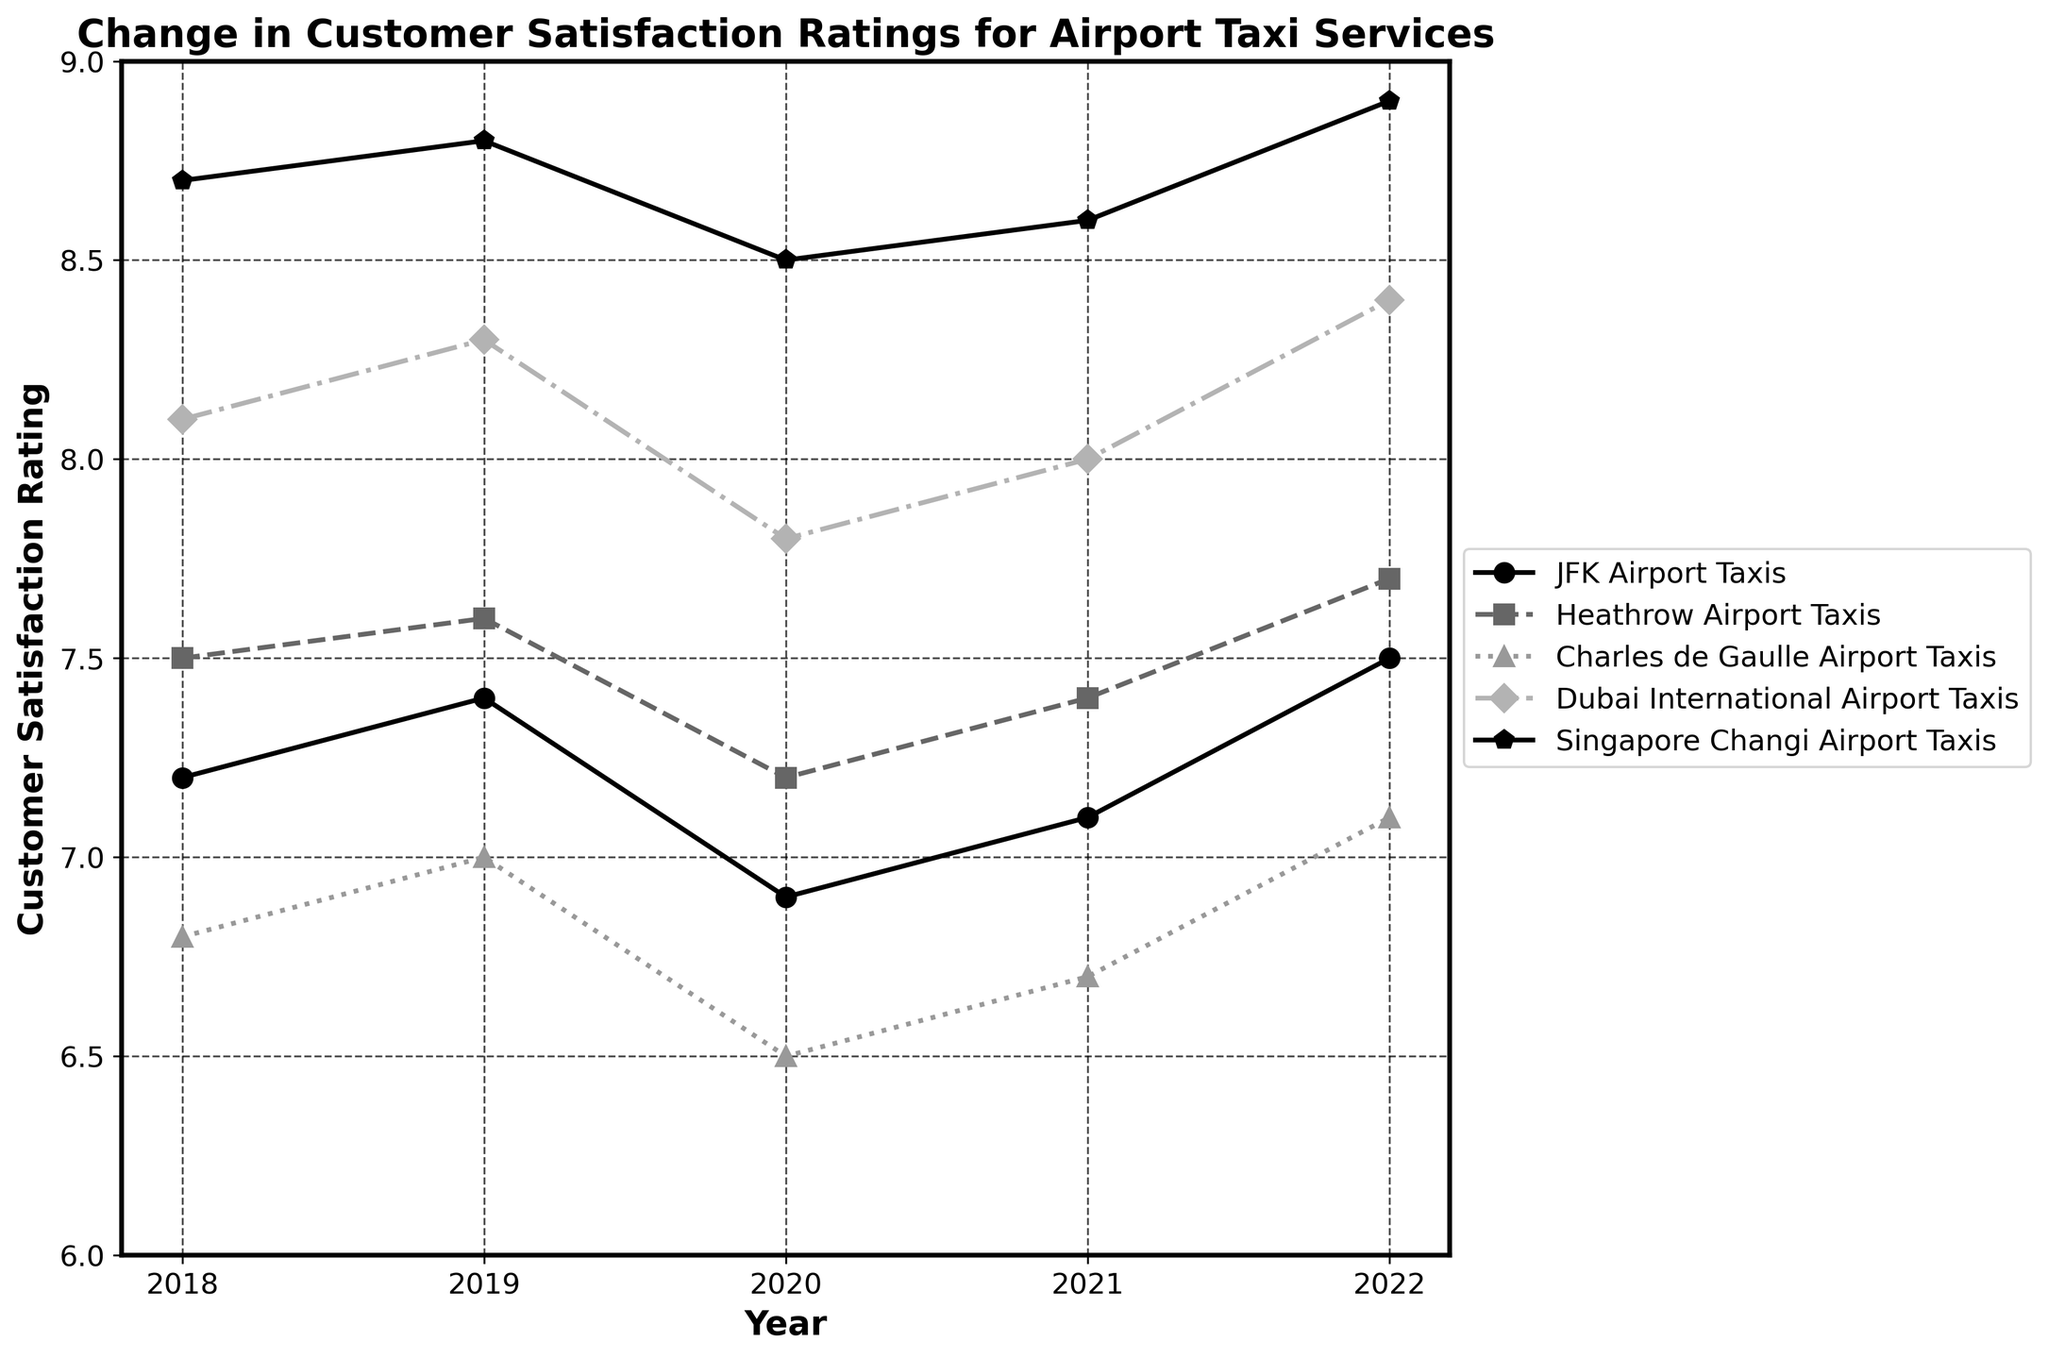What's the overall trend in customer satisfaction ratings for JFK Airport Taxis from 2018 to 2022? The customer satisfaction ratings for JFK Airport Taxis initially increased from 2018 (7.2) to 2019 (7.4). It then dropped to 6.9 in 2020, before rising again to 7.1 in 2021 and reaching 7.5 in 2022.
Answer: The general trend is positive with a slight dip in 2020 Which airport taxi service had the highest customer satisfaction rating in 2022? The plot shows that the Singapore Changi Airport Taxis had the highest rating in 2022 with a satisfaction score of 8.9.
Answer: Singapore Changi Airport Taxis How did the customer satisfaction ratings for Heathrow Airport Taxis change between 2019 and 2020? The rating for Heathrow Airport Taxis decreased from 7.6 in 2019 to 7.2 in 2020.
Answer: Decreased Did any airport taxi service have a decrease in customer satisfaction rating from 2021 to 2022? None of the data lines representing the airport taxi services show a downward trend from 2021 to 2022. All increased or stayed the same.
Answer: No Which years did the Dubai International Airport Taxis have a rating of 8.0 or higher? The line for Dubai International Airport Taxis is above 8.0 in the years 2018 (8.1), 2019 (8.3), 2021 (8.0), and 2022 (8.4). The only year it dropped below 8.0 is 2020 (7.8).
Answer: 2018, 2019, 2021, 2022 Compare the customer satisfaction ratings for Charles de Gaulle Airport Taxis in 2018 and 2020. Which year had a higher rating? In 2018, the customer satisfaction rating for Charles de Gaulle Airport Taxis was 6.8, while in 2020 it was 6.5. Therefore, the rating in 2018 was higher.
Answer: 2018 What is the difference in customer satisfaction ratings between JFK Airport Taxis and Singapore Changi Airport Taxis in 2020? In 2020, JFK Airport Taxis had a satisfaction rating of 6.9, while Singapore Changi Airport Taxis had a rating of 8.5. The difference is 8.5 - 6.9 = 1.6.
Answer: 1.6 Calculate the average customer satisfaction rating for Heathrow Airport Taxis over the five years. The ratings for Heathrow Airport Taxis are 7.5 (2018), 7.6 (2019), 7.2 (2020), 7.4 (2021), and 7.7 (2022). The average is (7.5 + 7.6 + 7.2 + 7.4 + 7.7) / 5 = 7.48.
Answer: 7.48 Which airport taxi service had the most consistent ratings over the period? Consistency can be observed by looking at which line is the most stable, with the least fluctuation in ratings. The Singapore Changi Airport Taxis ratings fluctuated very little, ranging narrowly between 8.5 and 8.9.
Answer: Singapore Changi Airport Taxis 